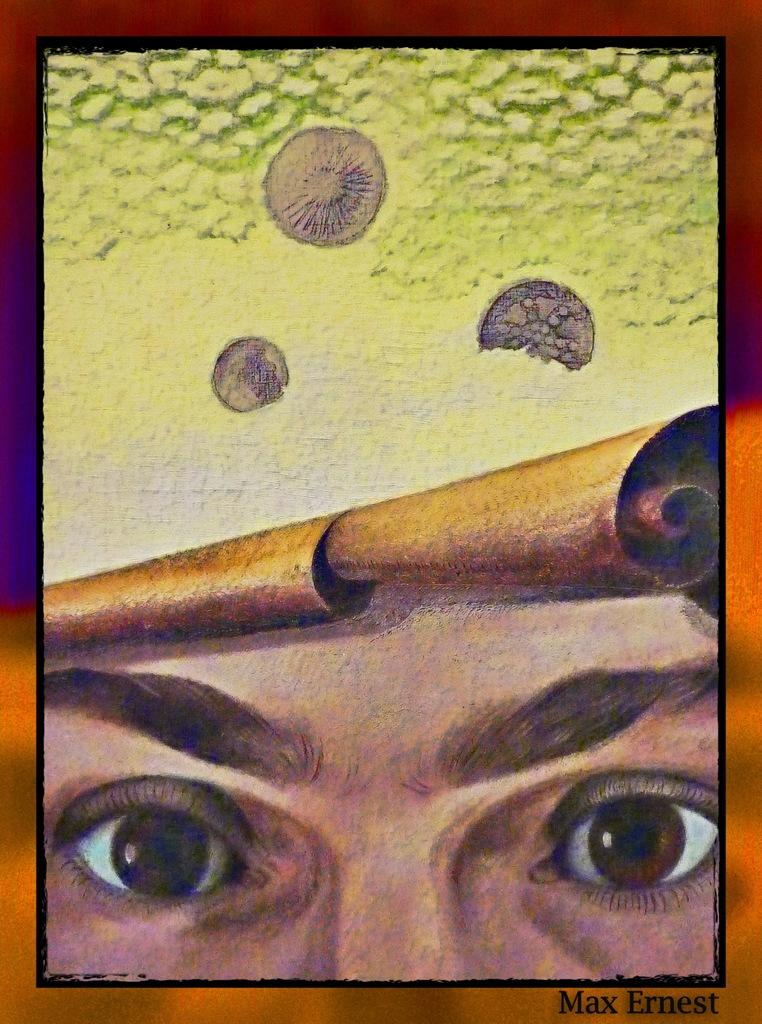What is the main subject of the image? There is a painting in the image. What can be found at the bottom of the painting? There is text at the bottom of the painting. What specific feature is visible within the painting? There are eyes visible in the painting. How many trees are depicted in the painting? There is no mention of trees in the image or the painting; only the text and eyes are mentioned. 